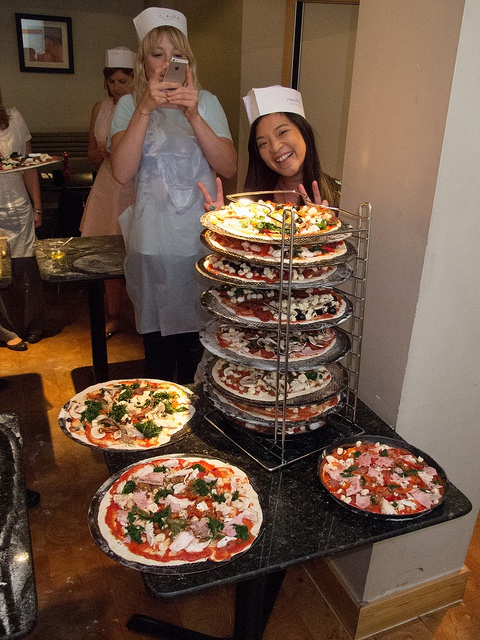Describe the objects in this image and their specific colors. I can see dining table in black, maroon, tan, and gray tones, people in black, gray, and brown tones, pizza in black, tan, and brown tones, people in black, brown, maroon, and lightgray tones, and pizza in black, lightpink, and brown tones in this image. 